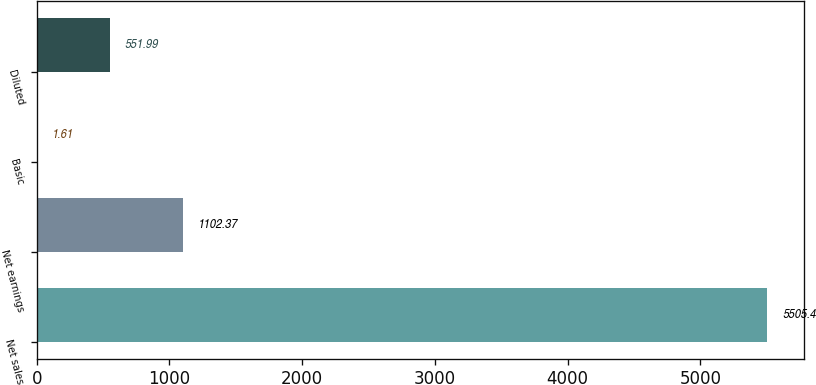Convert chart to OTSL. <chart><loc_0><loc_0><loc_500><loc_500><bar_chart><fcel>Net sales<fcel>Net earnings<fcel>Basic<fcel>Diluted<nl><fcel>5505.4<fcel>1102.37<fcel>1.61<fcel>551.99<nl></chart> 